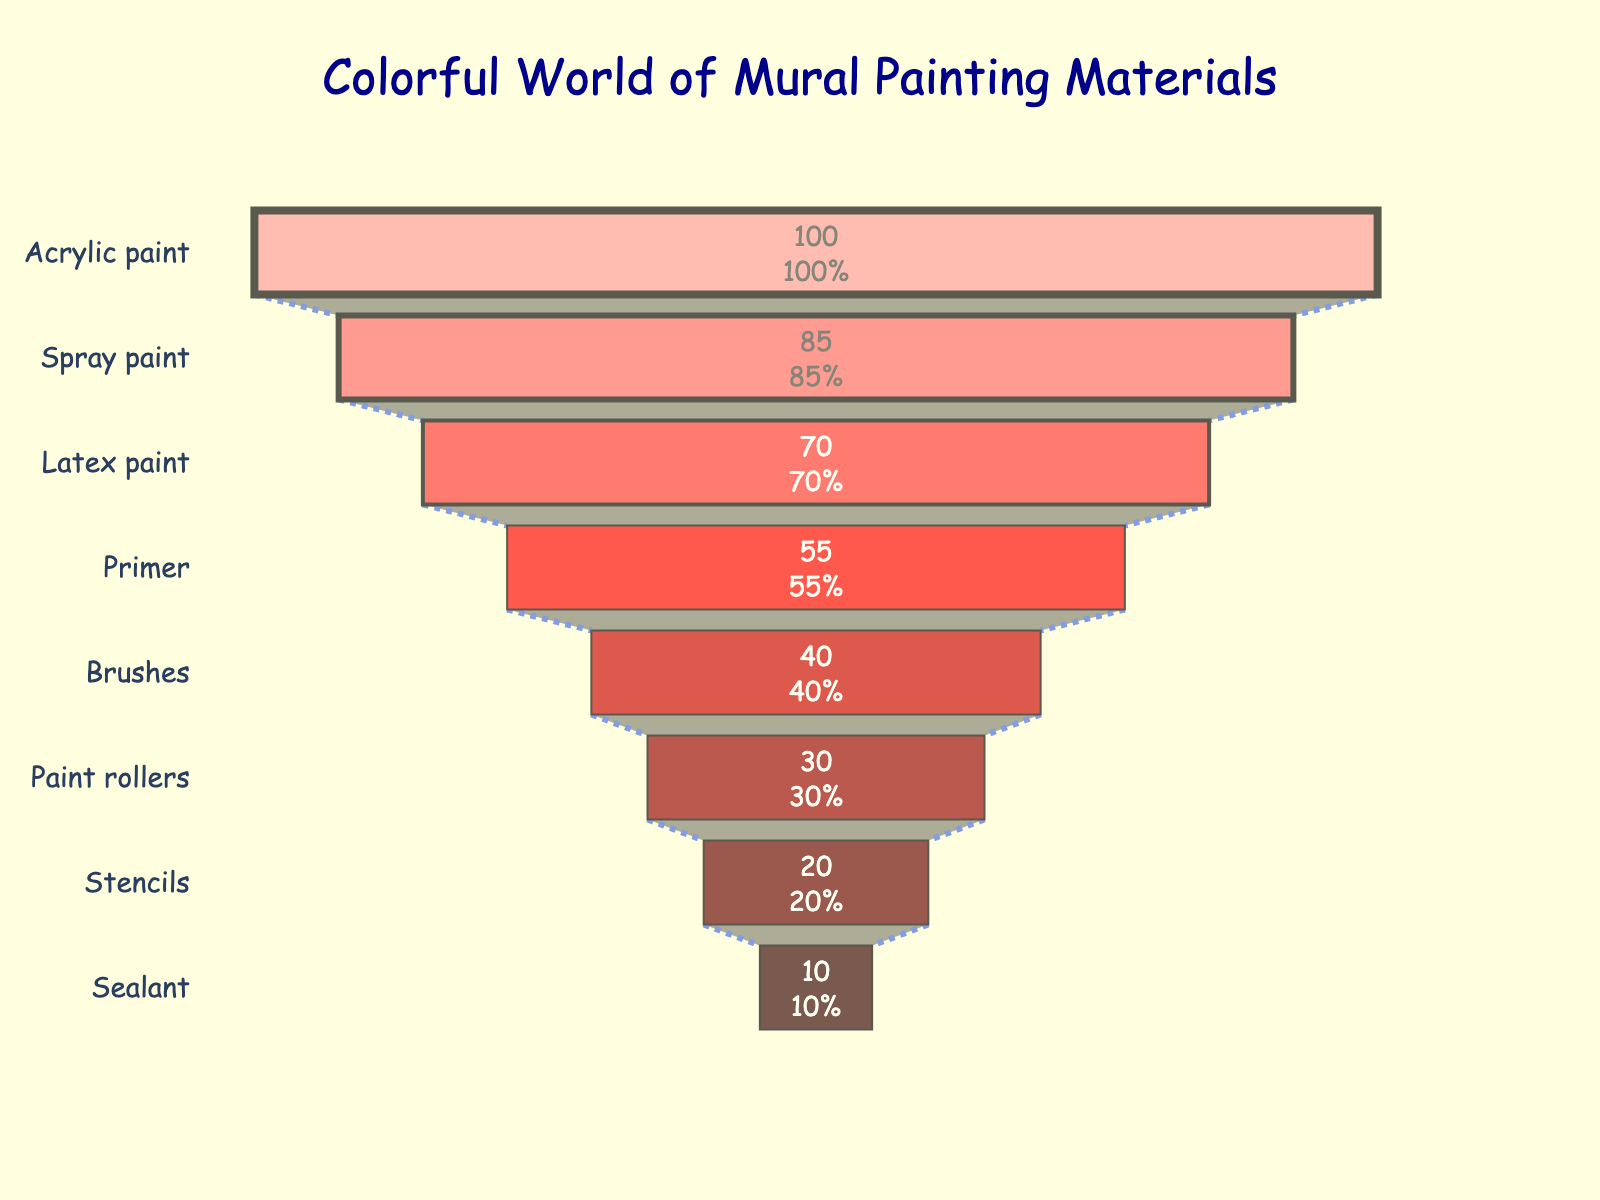What is the most frequently used material in mural painting? The funnel chart shows "Acrylic paint" at the top with the highest frequency value of 100.
Answer: Acrylic paint What is the least frequently used material in mural painting? The funnel chart shows "Sealant" at the bottom with the lowest frequency value of 10.
Answer: Sealant How many different materials are represented in the funnel chart? By counting the distinct segments within the funnel chart, there are 8 different materials.
Answer: 8 What is the combined frequency of Acrylic paint and Spray paint? Add the frequency values of Acrylic paint (100) and Spray paint (85): 100 + 85 = 185
Answer: 185 Which material has a higher frequency, Brushes or Paint rollers? The funnel chart shows "Brushes" with a frequency of 40 and "Paint rollers" with a frequency of 30, and 40 is greater than 30.
Answer: Brushes What is the percentage contribution of Stencils to the initial total frequency? The initial total frequency is the highest frequency value (Acrylic paint, 100). Stencils have a frequency of 20, so 20/100 * 100% = 20%.
Answer: 20% How much more frequently is Primer used compared to Sealant? The frequency of Primer is 55, and that of Sealant is 10. The difference is 55 - 10 = 45.
Answer: 45 Which materials have a frequency less than 50? The materials with a frequency less than 50 are Brushes (40), Paint rollers (30), Stencils (20), and Sealant (10).
Answer: Brushes, Paint rollers, Stencils, Sealant If you sum up the frequencies of the bottom three materials, what is the result? The frequencies of the bottom three materials are Paint rollers (30), Stencils (20), and Sealant (10). Summing them: 30 + 20 + 10 = 60.
Answer: 60 